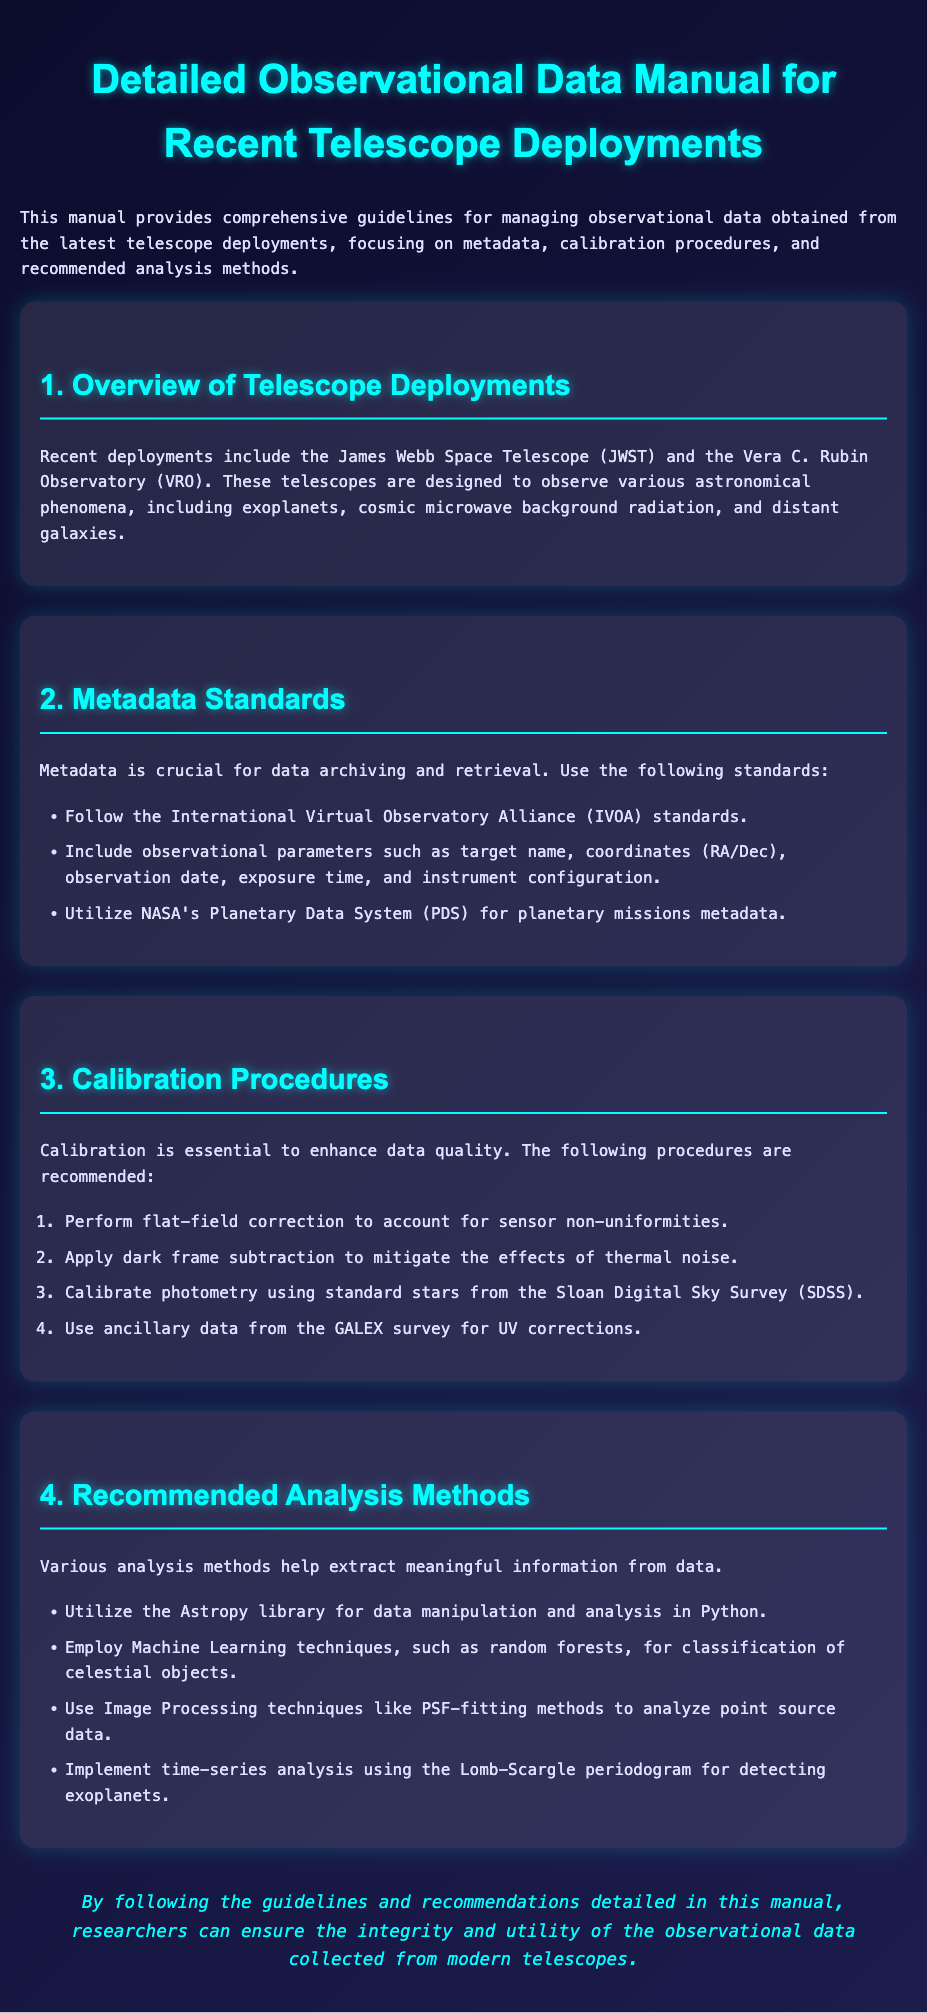What are the names of the recent telescope deployments mentioned? The document lists two recent telescope deployments: the James Webb Space Telescope and the Vera C. Rubin Observatory.
Answer: James Webb Space Telescope, Vera C. Rubin Observatory What is included in the metadata standards? The metadata standards include observational parameters such as target name, coordinates, observation date, exposure time, and instrument configuration.
Answer: Target name, coordinates, observation date, exposure time, instrument configuration What calibration procedure is recommended for thermal noise mitigation? The document states that dark frame subtraction is recommended to mitigate the effects of thermal noise.
Answer: Dark frame subtraction Which library is suggested for data manipulation in Python? The recommended library for data manipulation and analysis in Python is Astropy.
Answer: Astropy What type of analysis is used to detect exoplanets? The Lomb-Scargle periodogram is utilized for time-series analysis to detect exoplanets.
Answer: Lomb-Scargle periodogram Why is calibration important according to the document? Calibration is essential to enhance data quality, ensuring accuracy in the observational data.
Answer: Enhance data quality What standards should be followed for metadata? The document highlights following the International Virtual Observatory Alliance standards for metadata.
Answer: International Virtual Observatory Alliance standards What method is suggested for analyzing point source data? The document recommends using PSF-fitting methods for analyzing point source data.
Answer: PSF-fitting methods Which survey provides standard stars for photometry calibration? The Sloan Digital Sky Survey provides standard stars for photometry calibration.
Answer: Sloan Digital Sky Survey 